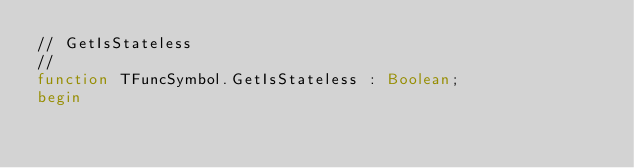Convert code to text. <code><loc_0><loc_0><loc_500><loc_500><_Pascal_>// GetIsStateless
//
function TFuncSymbol.GetIsStateless : Boolean;
begin</code> 